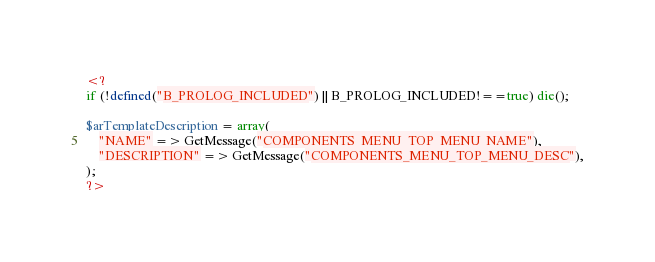<code> <loc_0><loc_0><loc_500><loc_500><_PHP_><?
if (!defined("B_PROLOG_INCLUDED") || B_PROLOG_INCLUDED!==true) die();

$arTemplateDescription = array(
	"NAME" => GetMessage("COMPONENTS_MENU_TOP_MENU_NAME"),
	"DESCRIPTION" => GetMessage("COMPONENTS_MENU_TOP_MENU_DESC"),
);
?></code> 